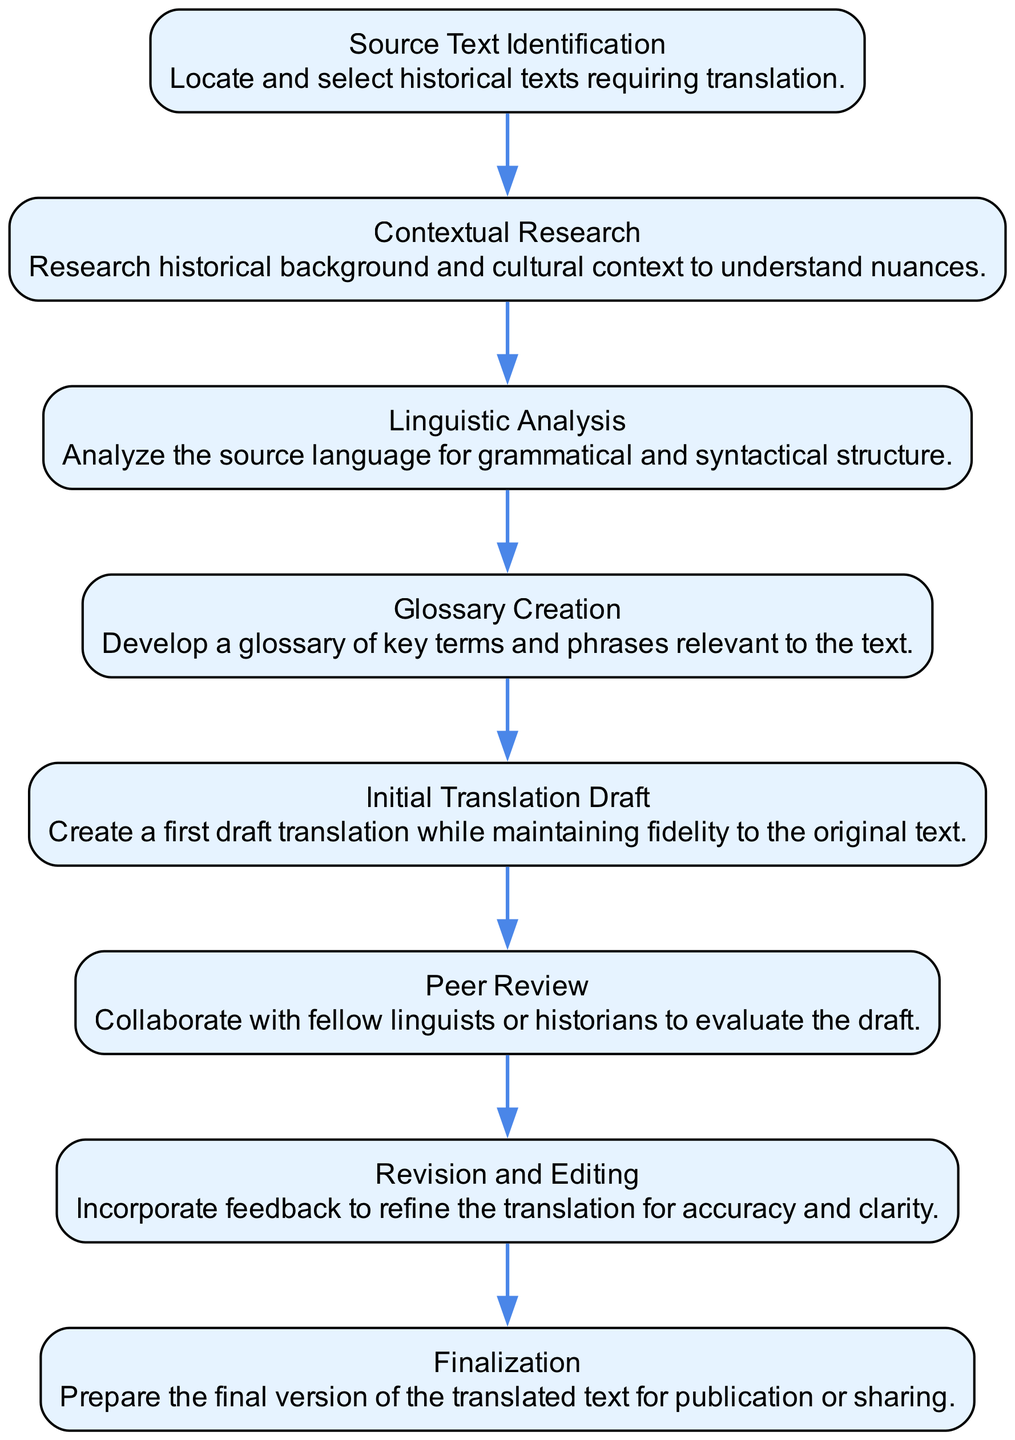What is the first step in the translation process? The first step in the diagram is "Source Text Identification," where you locate and select historical texts required for translation.
Answer: Source Text Identification How many total steps are outlined in the translation process? The diagram lists eight distinct steps, starting from "Source Text Identification" to "Finalization."
Answer: 8 Which step involves creating a glossary? The step that involves creating a glossary is "Glossary Creation," which focuses on developing key terms and phrases relevant to the text.
Answer: Glossary Creation What are the two steps following "Initial Translation Draft"? The steps following "Initial Translation Draft" are "Peer Review" and "Revision and Editing," indicating a collaborative and revising phase after the first draft is created.
Answer: Peer Review and Revision and Editing What is the last step in the translation process? The last step in the flow chart is "Finalization," where the final version of the translated text is prepared for publication or sharing.
Answer: Finalization Which steps involve collaboration or feedback? "Peer Review" and "Revision and Editing" are the steps that involve collaboration with others and the incorporation of feedback into the translation process.
Answer: Peer Review and Revision and Editing Which two steps focus on understanding the source text? The two steps that focus on understanding the source text are "Contextual Research" and "Linguistic Analysis," helping to grasp historical and grammatical nuances.
Answer: Contextual Research and Linguistic Analysis How does the "Linguistic Analysis" step relate to "Initial Translation Draft"? "Linguistic Analysis" focuses on analyzing the source language's structure, providing foundational knowledge that influences the "Initial Translation Draft," where this understanding is applied.
Answer: Provides foundational knowledge for the draft 